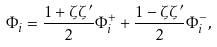Convert formula to latex. <formula><loc_0><loc_0><loc_500><loc_500>\Phi _ { i } = \frac { 1 + \zeta \zeta ^ { \prime } } { 2 } \Phi ^ { + } _ { i } + \frac { 1 - \zeta \zeta ^ { \prime } } { 2 } \Phi ^ { - } _ { i } ,</formula> 